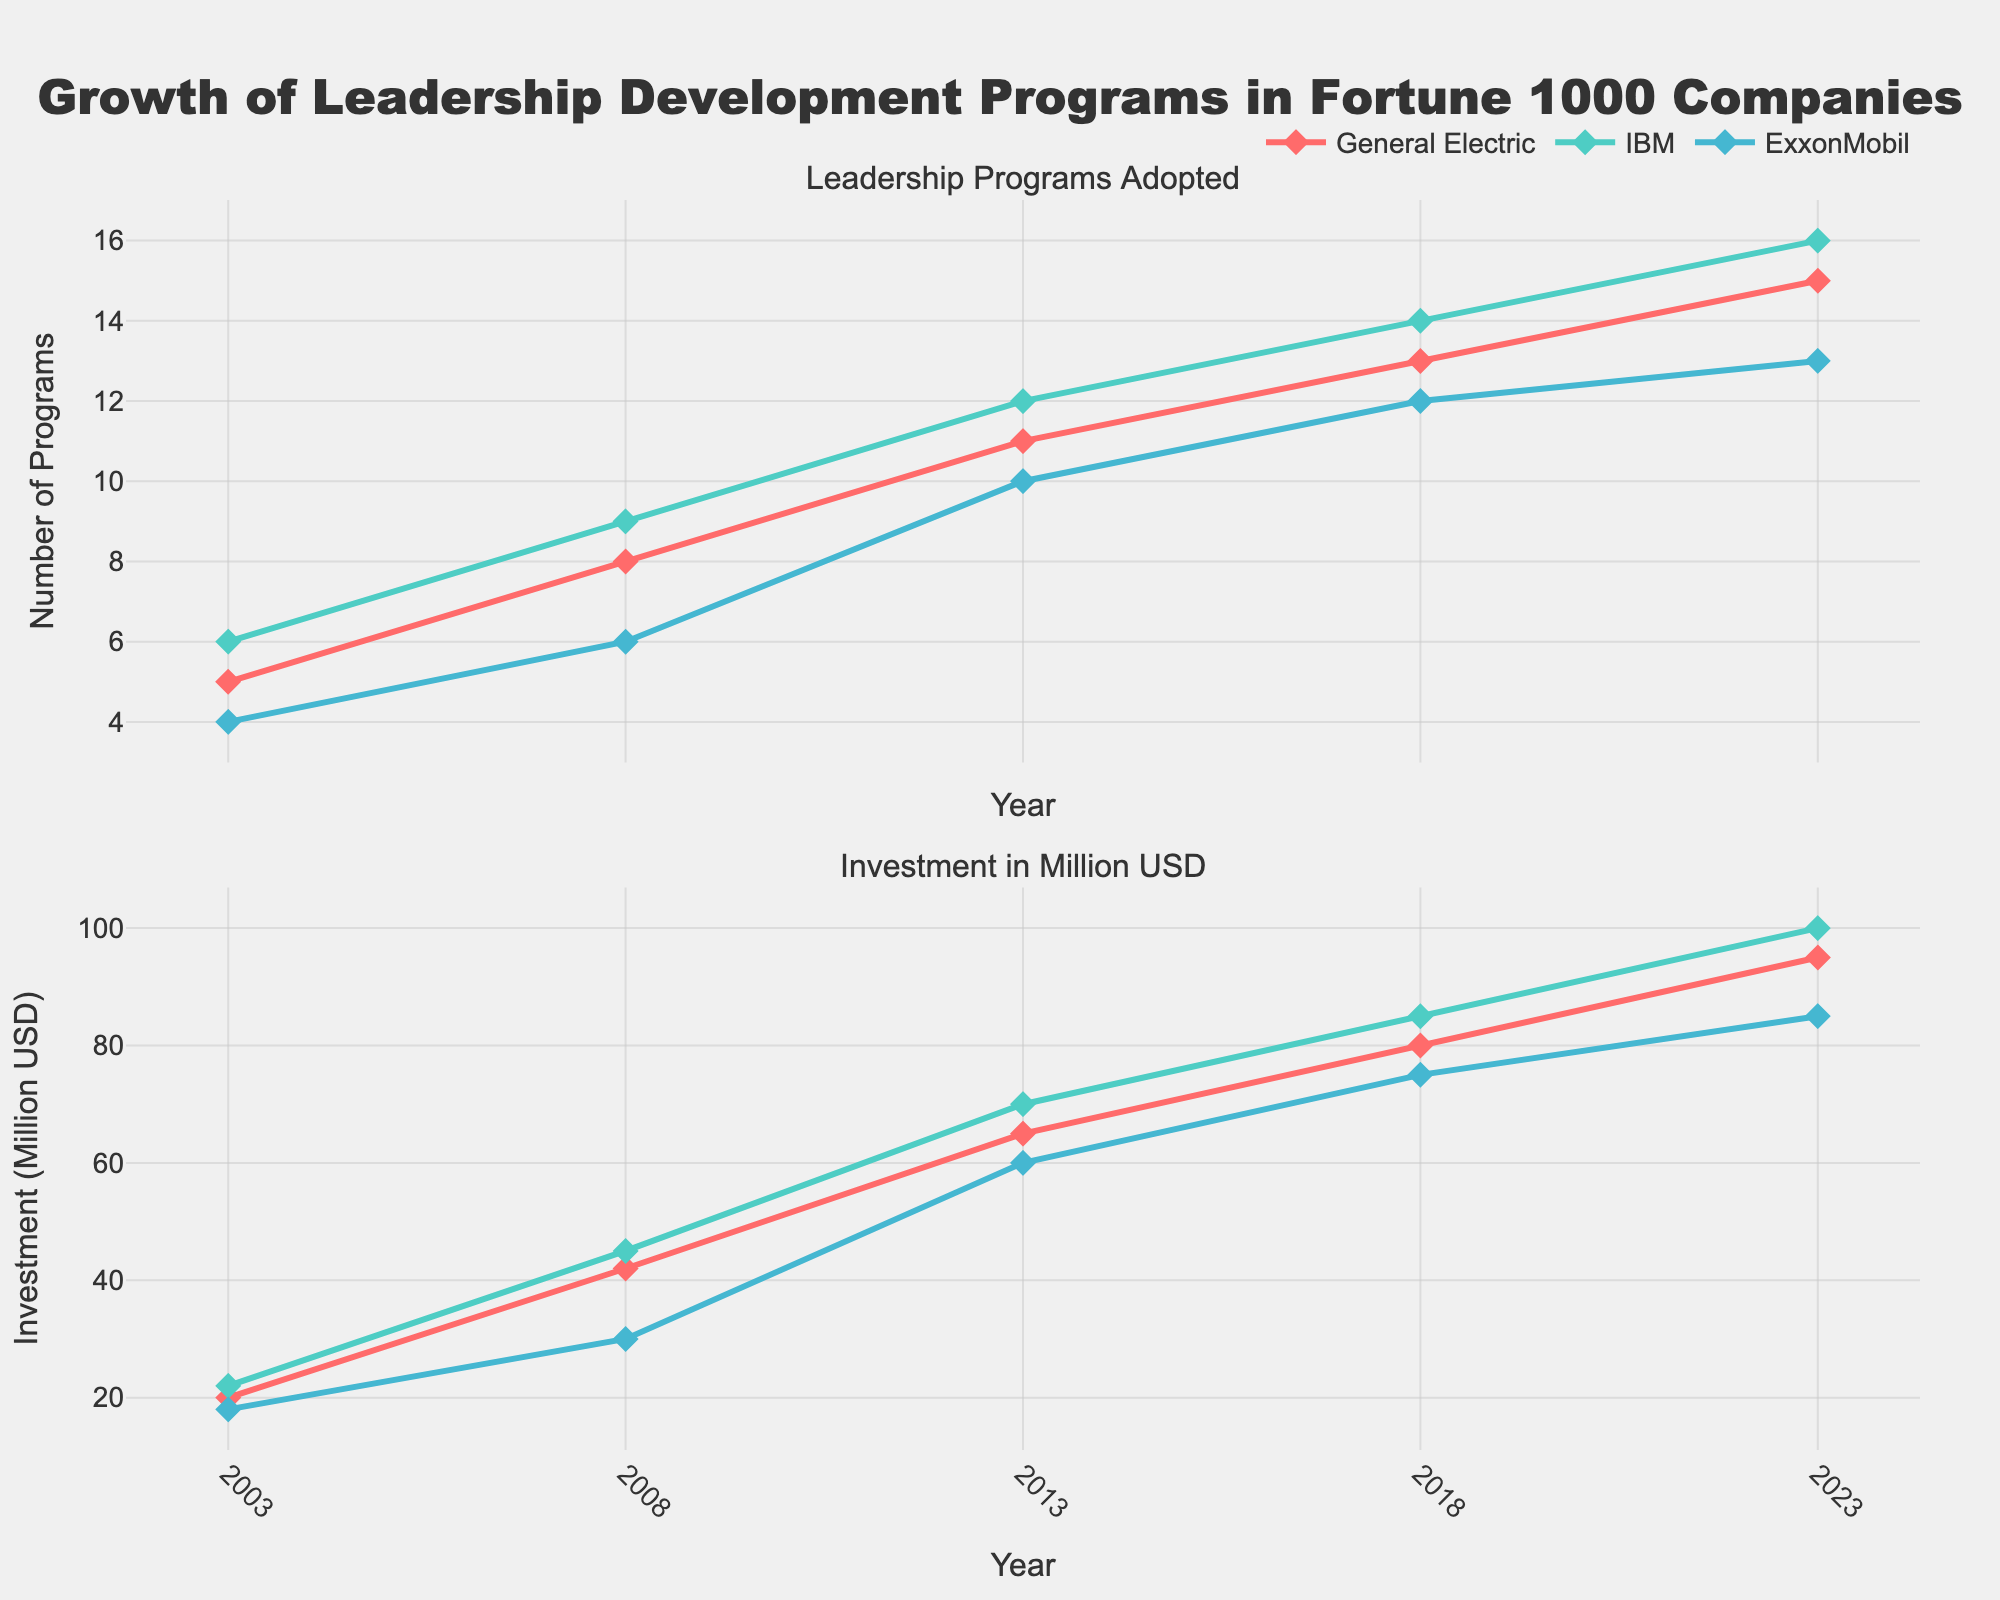Which company had the highest number of leadership programs adopted in 2023? Look at the first subplot, navigate to the year 2023, and compare the data points for each company. IBM has the highest point.
Answer: IBM How did the investment in leadership programs for ExxonMobil change from 2003 to 2023? Look at the second subplot, locate ExxonMobil's investment in 2003 (18 million USD) and 2023 (85 million USD), then find the difference.
Answer: Increased by 67 million USD Which company showed the most consistent growth in the number of leadership programs adopted over the two decades? Observe the trend lines in the first subplot for all companies. IBM shows a steady upward trend without erratic changes.
Answer: IBM What is the average investment amount in 2013 for all three companies? Add the investment values for each company in 2013: (65 for GE + 70 for IBM + 60 for ExxonMobil) and divide by 3.
Answer: 65 million USD Compare the investment in leadership programs between General Electric and IBM over the years. Which company consistently invested more? Check both companies' lines in the second subplot across all years. IBM's line is consistently above General Electric's line.
Answer: IBM How many leadership programs did General Electric add between 2008 and 2018? Look at the data points for General Electric in 2008 (8 programs) and 2018 (13 programs) in the first subplot, then find the difference.
Answer: 5 programs Which company had the largest increase in leadership program adoption between any two consecutive data points? Compare increments for each company in the first subplot. IBM had an increase from 6 to 9 between 2003 and 2008, which is the largest jump of 3.
Answer: IBM What was the trend in investment for General Electric from 2003 to 2023? Observe the second subplot for General Electric from 2003 (20 million USD) to 2023 (95 million USD). The trend shows a continuous increase.
Answer: Continuous increase Which year had the highest collective investment across all companies? Sum the investments for all companies per year and find the highest total. 2023 has (95 + 100 + 85) = 280 million USD, which is the highest.
Answer: 2023 